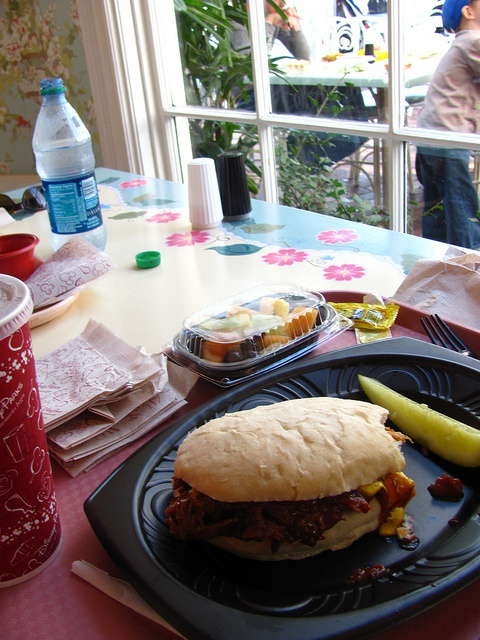Describe the objects in this image and their specific colors. I can see dining table in olive, black, lightgray, maroon, and darkgray tones, sandwich in olive, black, beige, maroon, and tan tones, cup in olive, maroon, brown, and darkgray tones, people in olive, black, darkgray, navy, and lightgray tones, and bottle in olive, darkgray, lightgray, and lightblue tones in this image. 